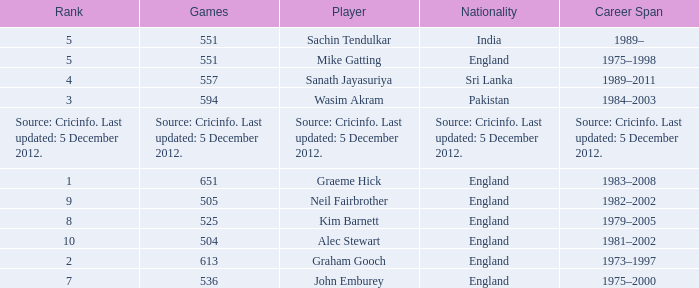Could you parse the entire table? {'header': ['Rank', 'Games', 'Player', 'Nationality', 'Career Span'], 'rows': [['5', '551', 'Sachin Tendulkar', 'India', '1989–'], ['5', '551', 'Mike Gatting', 'England', '1975–1998'], ['4', '557', 'Sanath Jayasuriya', 'Sri Lanka', '1989–2011'], ['3', '594', 'Wasim Akram', 'Pakistan', '1984–2003'], ['Source: Cricinfo. Last updated: 5 December 2012.', 'Source: Cricinfo. Last updated: 5 December 2012.', 'Source: Cricinfo. Last updated: 5 December 2012.', 'Source: Cricinfo. Last updated: 5 December 2012.', 'Source: Cricinfo. Last updated: 5 December 2012.'], ['1', '651', 'Graeme Hick', 'England', '1983–2008'], ['9', '505', 'Neil Fairbrother', 'England', '1982–2002'], ['8', '525', 'Kim Barnett', 'England', '1979–2005'], ['10', '504', 'Alec Stewart', 'England', '1981–2002'], ['2', '613', 'Graham Gooch', 'England', '1973–1997'], ['7', '536', 'John Emburey', 'England', '1975–2000']]} What is Wasim Akram's rank? 3.0. 